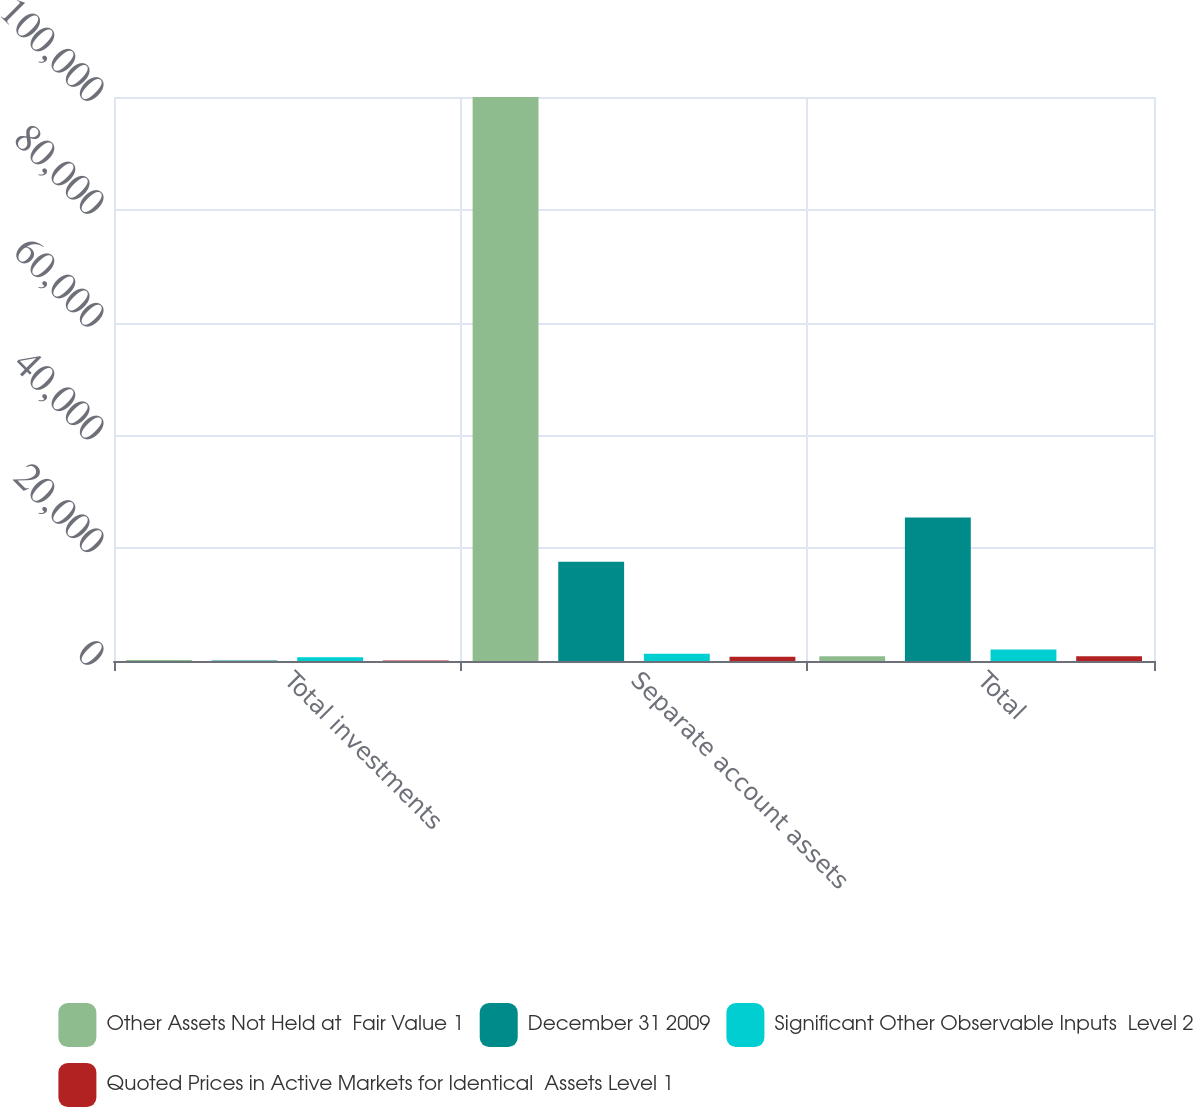<chart> <loc_0><loc_0><loc_500><loc_500><stacked_bar_chart><ecel><fcel>Total investments<fcel>Separate account assets<fcel>Total<nl><fcel>Other Assets Not Held at  Fair Value 1<fcel>193<fcel>99983<fcel>844<nl><fcel>December 31 2009<fcel>84<fcel>17599<fcel>25449<nl><fcel>Significant Other Observable Inputs  Level 2<fcel>683<fcel>1292<fcel>2021<nl><fcel>Quoted Prices in Active Markets for Identical  Assets Level 1<fcel>89<fcel>755<fcel>844<nl></chart> 